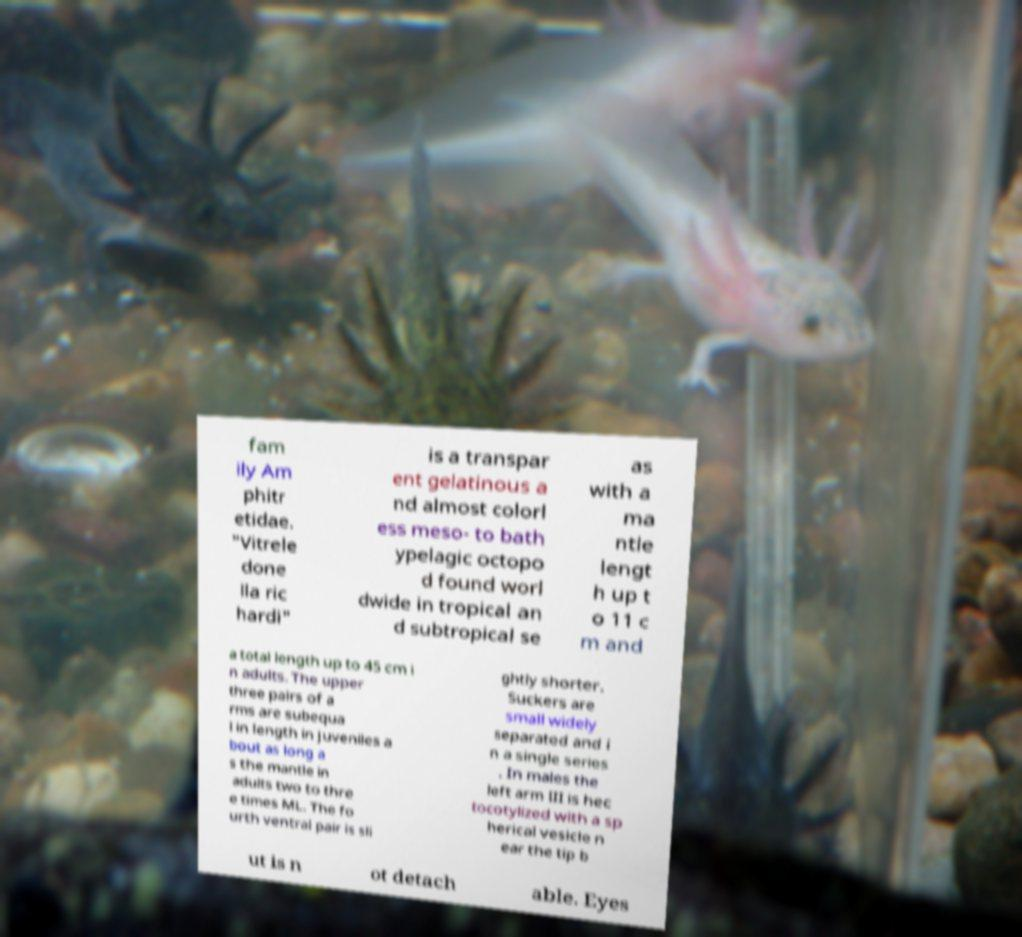What messages or text are displayed in this image? I need them in a readable, typed format. fam ily Am phitr etidae. "Vitrele done lla ric hardi" is a transpar ent gelatinous a nd almost colorl ess meso- to bath ypelagic octopo d found worl dwide in tropical an d subtropical se as with a ma ntle lengt h up t o 11 c m and a total length up to 45 cm i n adults. The upper three pairs of a rms are subequa l in length in juveniles a bout as long a s the mantle in adults two to thre e times ML. The fo urth ventral pair is sli ghtly shorter. Suckers are small widely separated and i n a single series . In males the left arm III is hec tocotylized with a sp herical vesicle n ear the tip b ut is n ot detach able. Eyes 